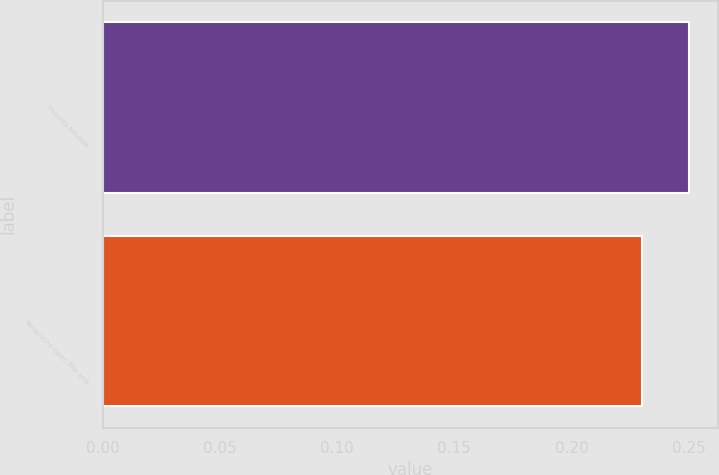Convert chart. <chart><loc_0><loc_0><loc_500><loc_500><bar_chart><fcel>Phoenix Nevada<fcel>Yanacocha Open Pits and<nl><fcel>0.25<fcel>0.23<nl></chart> 